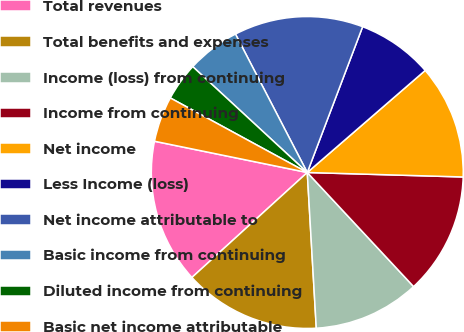<chart> <loc_0><loc_0><loc_500><loc_500><pie_chart><fcel>Total revenues<fcel>Total benefits and expenses<fcel>Income (loss) from continuing<fcel>Income from continuing<fcel>Net income<fcel>Less Income (loss)<fcel>Net income attributable to<fcel>Basic income from continuing<fcel>Diluted income from continuing<fcel>Basic net income attributable<nl><fcel>14.96%<fcel>14.17%<fcel>11.02%<fcel>12.6%<fcel>11.81%<fcel>7.87%<fcel>13.39%<fcel>5.51%<fcel>3.94%<fcel>4.72%<nl></chart> 